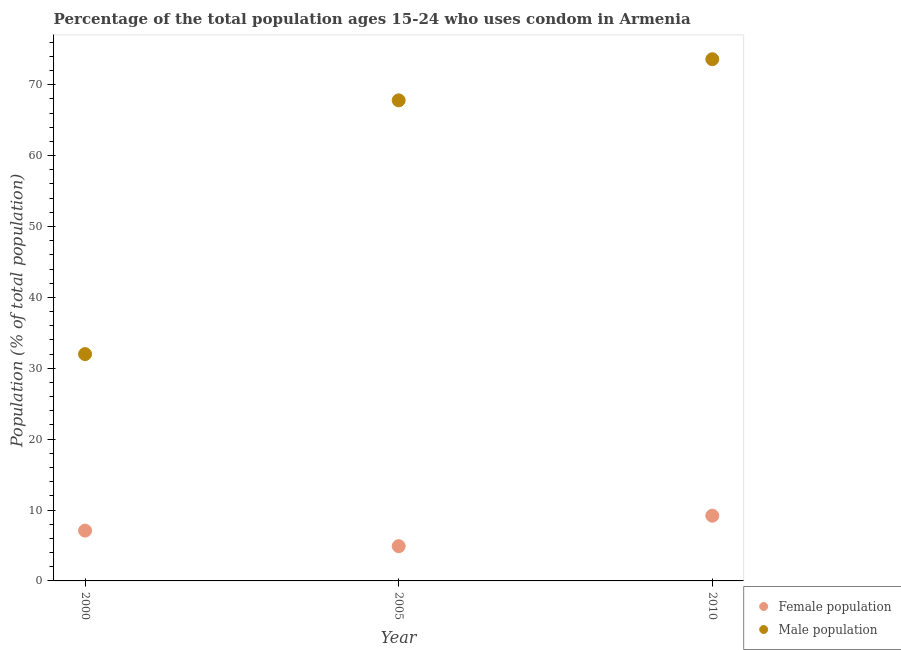How many different coloured dotlines are there?
Give a very brief answer. 2. Is the number of dotlines equal to the number of legend labels?
Give a very brief answer. Yes. What is the male population in 2000?
Your response must be concise. 32. Across all years, what is the maximum male population?
Offer a terse response. 73.6. In which year was the male population minimum?
Provide a succinct answer. 2000. What is the total male population in the graph?
Provide a short and direct response. 173.4. What is the difference between the male population in 2000 and that in 2005?
Your answer should be compact. -35.8. What is the difference between the male population in 2010 and the female population in 2000?
Your answer should be very brief. 66.5. What is the average female population per year?
Keep it short and to the point. 7.07. In the year 2000, what is the difference between the male population and female population?
Offer a terse response. 24.9. In how many years, is the female population greater than 54 %?
Give a very brief answer. 0. What is the ratio of the female population in 2005 to that in 2010?
Your answer should be very brief. 0.53. Is the male population in 2000 less than that in 2005?
Your answer should be very brief. Yes. What is the difference between the highest and the second highest female population?
Offer a terse response. 2.1. What is the difference between the highest and the lowest male population?
Offer a very short reply. 41.6. Is the sum of the female population in 2000 and 2005 greater than the maximum male population across all years?
Provide a succinct answer. No. Does the male population monotonically increase over the years?
Ensure brevity in your answer.  Yes. Is the male population strictly less than the female population over the years?
Offer a terse response. No. How many years are there in the graph?
Give a very brief answer. 3. How are the legend labels stacked?
Offer a terse response. Vertical. What is the title of the graph?
Make the answer very short. Percentage of the total population ages 15-24 who uses condom in Armenia. What is the label or title of the X-axis?
Your answer should be compact. Year. What is the label or title of the Y-axis?
Provide a short and direct response. Population (% of total population) . What is the Population (% of total population)  in Male population in 2005?
Make the answer very short. 67.8. What is the Population (% of total population)  of Female population in 2010?
Make the answer very short. 9.2. What is the Population (% of total population)  of Male population in 2010?
Provide a succinct answer. 73.6. Across all years, what is the maximum Population (% of total population)  of Female population?
Give a very brief answer. 9.2. Across all years, what is the maximum Population (% of total population)  in Male population?
Provide a short and direct response. 73.6. Across all years, what is the minimum Population (% of total population)  in Female population?
Your answer should be very brief. 4.9. What is the total Population (% of total population)  in Female population in the graph?
Offer a terse response. 21.2. What is the total Population (% of total population)  of Male population in the graph?
Your answer should be compact. 173.4. What is the difference between the Population (% of total population)  of Female population in 2000 and that in 2005?
Keep it short and to the point. 2.2. What is the difference between the Population (% of total population)  of Male population in 2000 and that in 2005?
Ensure brevity in your answer.  -35.8. What is the difference between the Population (% of total population)  in Female population in 2000 and that in 2010?
Ensure brevity in your answer.  -2.1. What is the difference between the Population (% of total population)  in Male population in 2000 and that in 2010?
Keep it short and to the point. -41.6. What is the difference between the Population (% of total population)  of Female population in 2000 and the Population (% of total population)  of Male population in 2005?
Provide a short and direct response. -60.7. What is the difference between the Population (% of total population)  in Female population in 2000 and the Population (% of total population)  in Male population in 2010?
Make the answer very short. -66.5. What is the difference between the Population (% of total population)  of Female population in 2005 and the Population (% of total population)  of Male population in 2010?
Your response must be concise. -68.7. What is the average Population (% of total population)  in Female population per year?
Make the answer very short. 7.07. What is the average Population (% of total population)  of Male population per year?
Ensure brevity in your answer.  57.8. In the year 2000, what is the difference between the Population (% of total population)  in Female population and Population (% of total population)  in Male population?
Keep it short and to the point. -24.9. In the year 2005, what is the difference between the Population (% of total population)  of Female population and Population (% of total population)  of Male population?
Your response must be concise. -62.9. In the year 2010, what is the difference between the Population (% of total population)  in Female population and Population (% of total population)  in Male population?
Ensure brevity in your answer.  -64.4. What is the ratio of the Population (% of total population)  in Female population in 2000 to that in 2005?
Keep it short and to the point. 1.45. What is the ratio of the Population (% of total population)  of Male population in 2000 to that in 2005?
Offer a very short reply. 0.47. What is the ratio of the Population (% of total population)  of Female population in 2000 to that in 2010?
Provide a short and direct response. 0.77. What is the ratio of the Population (% of total population)  of Male population in 2000 to that in 2010?
Your answer should be compact. 0.43. What is the ratio of the Population (% of total population)  in Female population in 2005 to that in 2010?
Offer a terse response. 0.53. What is the ratio of the Population (% of total population)  in Male population in 2005 to that in 2010?
Give a very brief answer. 0.92. What is the difference between the highest and the second highest Population (% of total population)  of Male population?
Ensure brevity in your answer.  5.8. What is the difference between the highest and the lowest Population (% of total population)  in Male population?
Provide a short and direct response. 41.6. 